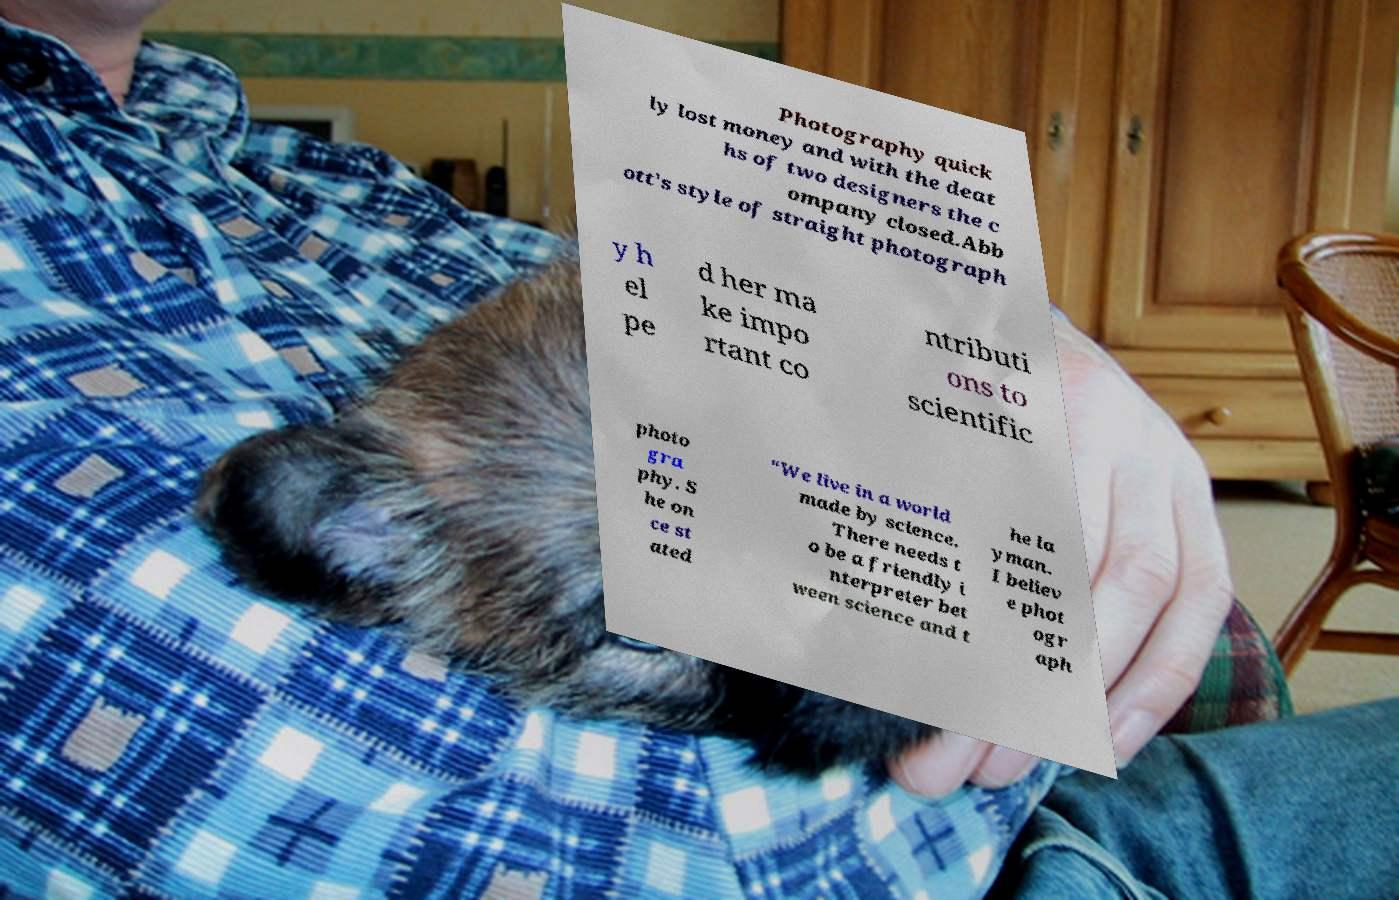There's text embedded in this image that I need extracted. Can you transcribe it verbatim? Photography quick ly lost money and with the deat hs of two designers the c ompany closed.Abb ott's style of straight photograph y h el pe d her ma ke impo rtant co ntributi ons to scientific photo gra phy. S he on ce st ated “We live in a world made by science. There needs t o be a friendly i nterpreter bet ween science and t he la yman. I believ e phot ogr aph 